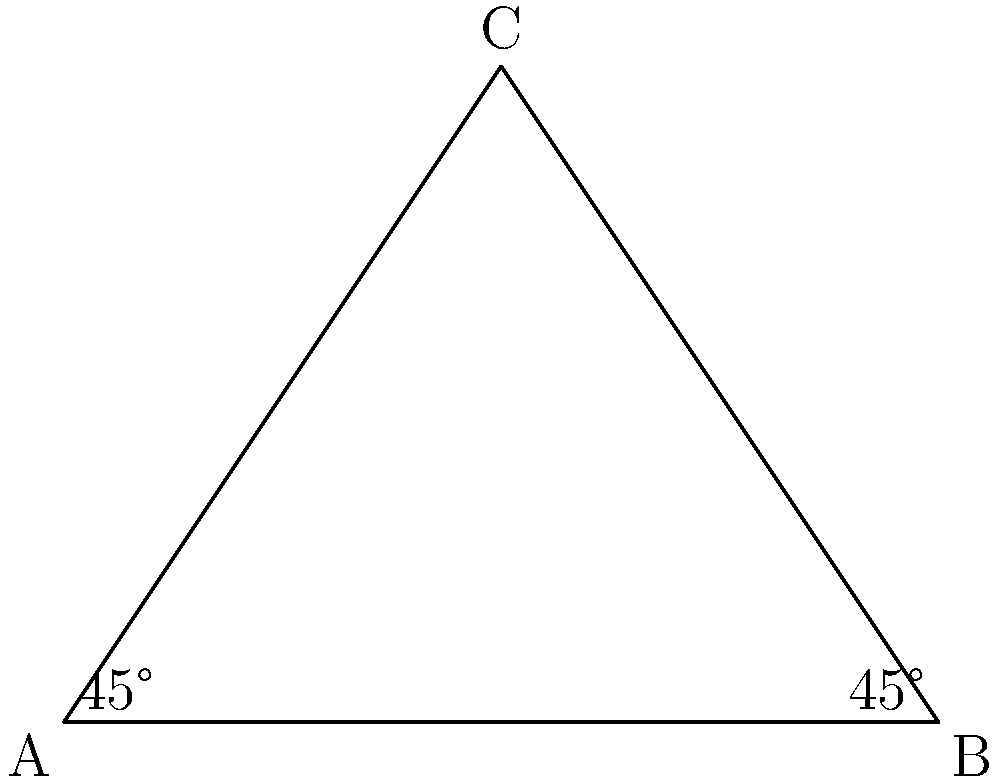Super LEGO Hero, I found this amazing triangular roof piece for my LEGO house! The base angles are both 45°. Can you help me figure out what the angle at the top (angle C) is? Great question, young LEGO builder! Let's solve this step-by-step:

1) First, remember that the sum of all angles in a triangle is always 180°.

2) We know that the two base angles (A and B) are both 45°.

3) Let's add these known angles:
   $45° + 45° = 90°$

4) Now, to find angle C, we need to subtract the sum of the known angles from 180°:
   $180° - 90° = 90°$

5) Therefore, angle C must be 90°.

This makes our roof piece a special kind of triangle called a right-angled isosceles triangle. The right angle at the top makes it perfect for a sturdy LEGO roof!
Answer: 90° 